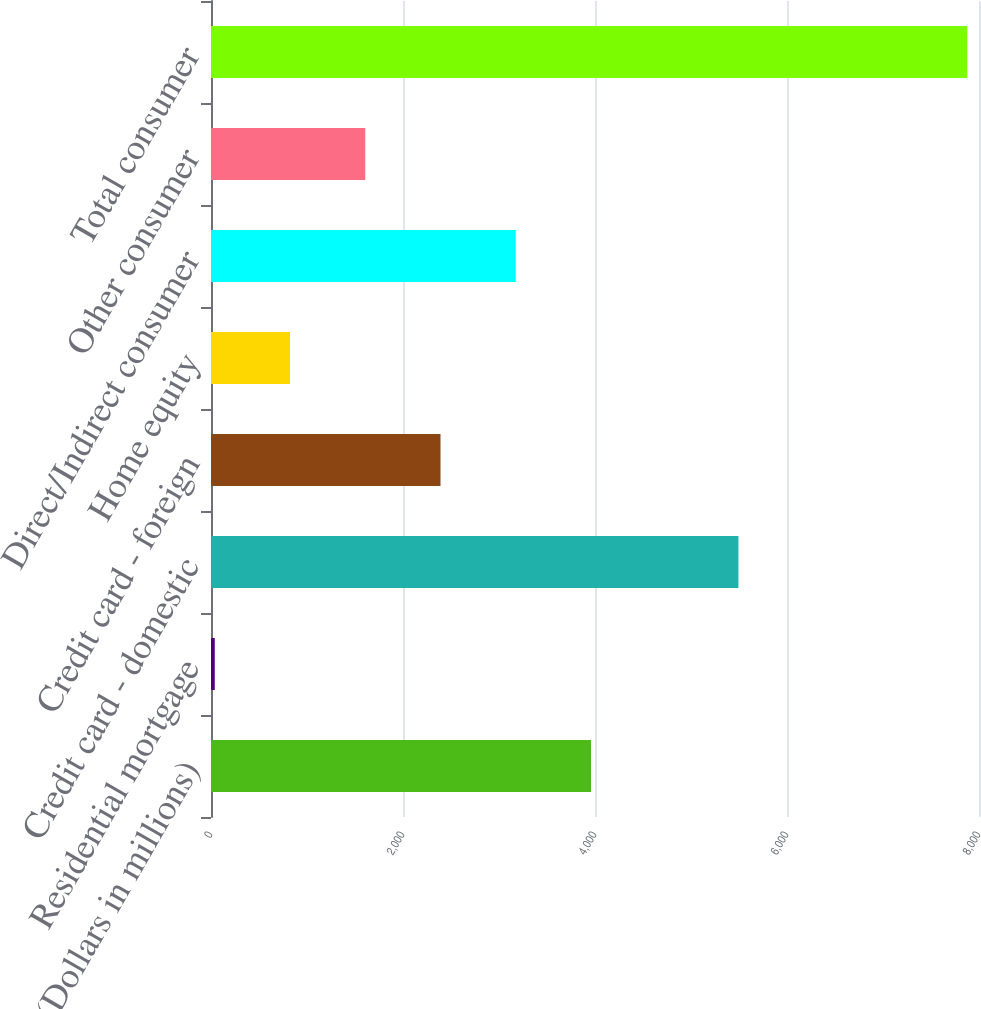<chart> <loc_0><loc_0><loc_500><loc_500><bar_chart><fcel>(Dollars in millions)<fcel>Residential mortgage<fcel>Credit card - domestic<fcel>Credit card - foreign<fcel>Home equity<fcel>Direct/Indirect consumer<fcel>Other consumer<fcel>Total consumer<nl><fcel>3958.5<fcel>39<fcel>5494<fcel>2390.7<fcel>822.9<fcel>3174.6<fcel>1606.8<fcel>7878<nl></chart> 